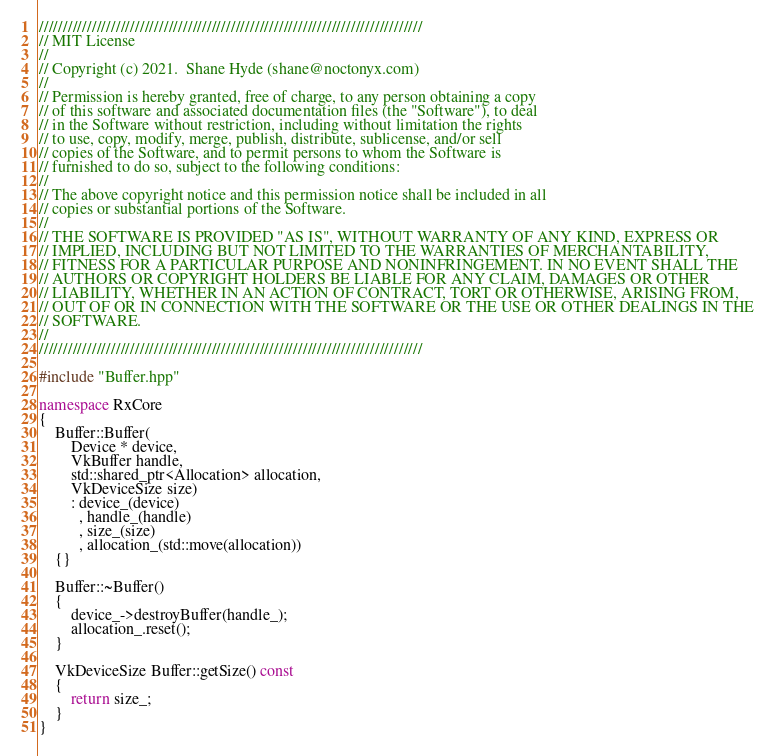<code> <loc_0><loc_0><loc_500><loc_500><_C++_>////////////////////////////////////////////////////////////////////////////////
// MIT License
//
// Copyright (c) 2021.  Shane Hyde (shane@noctonyx.com)
//
// Permission is hereby granted, free of charge, to any person obtaining a copy
// of this software and associated documentation files (the "Software"), to deal
// in the Software without restriction, including without limitation the rights
// to use, copy, modify, merge, publish, distribute, sublicense, and/or sell
// copies of the Software, and to permit persons to whom the Software is
// furnished to do so, subject to the following conditions:
//
// The above copyright notice and this permission notice shall be included in all
// copies or substantial portions of the Software.
//
// THE SOFTWARE IS PROVIDED "AS IS", WITHOUT WARRANTY OF ANY KIND, EXPRESS OR
// IMPLIED, INCLUDING BUT NOT LIMITED TO THE WARRANTIES OF MERCHANTABILITY,
// FITNESS FOR A PARTICULAR PURPOSE AND NONINFRINGEMENT. IN NO EVENT SHALL THE
// AUTHORS OR COPYRIGHT HOLDERS BE LIABLE FOR ANY CLAIM, DAMAGES OR OTHER
// LIABILITY, WHETHER IN AN ACTION OF CONTRACT, TORT OR OTHERWISE, ARISING FROM,
// OUT OF OR IN CONNECTION WITH THE SOFTWARE OR THE USE OR OTHER DEALINGS IN THE
// SOFTWARE.
//
////////////////////////////////////////////////////////////////////////////////

#include "Buffer.hpp"

namespace RxCore
{
    Buffer::Buffer(
        Device * device,
        VkBuffer handle,
        std::shared_ptr<Allocation> allocation,
        VkDeviceSize size)
        : device_(device)
          , handle_(handle)
          , size_(size)
          , allocation_(std::move(allocation))
    {}

    Buffer::~Buffer()
    {
        device_->destroyBuffer(handle_);
        allocation_.reset();
    }

    VkDeviceSize Buffer::getSize() const
    {
        return size_;
    }
}
</code> 